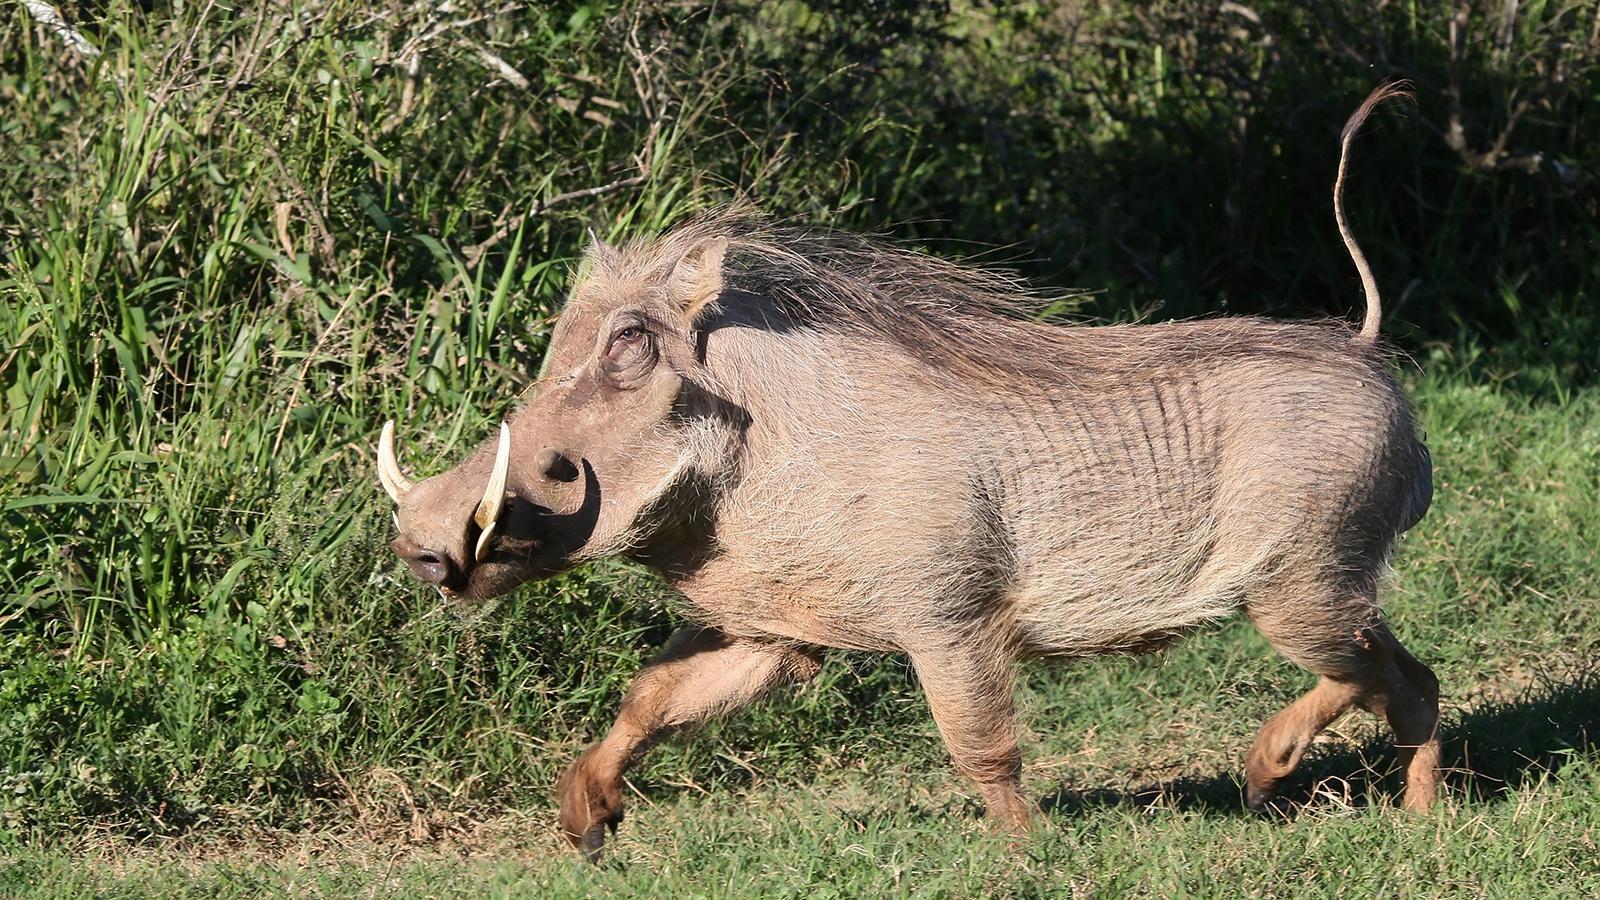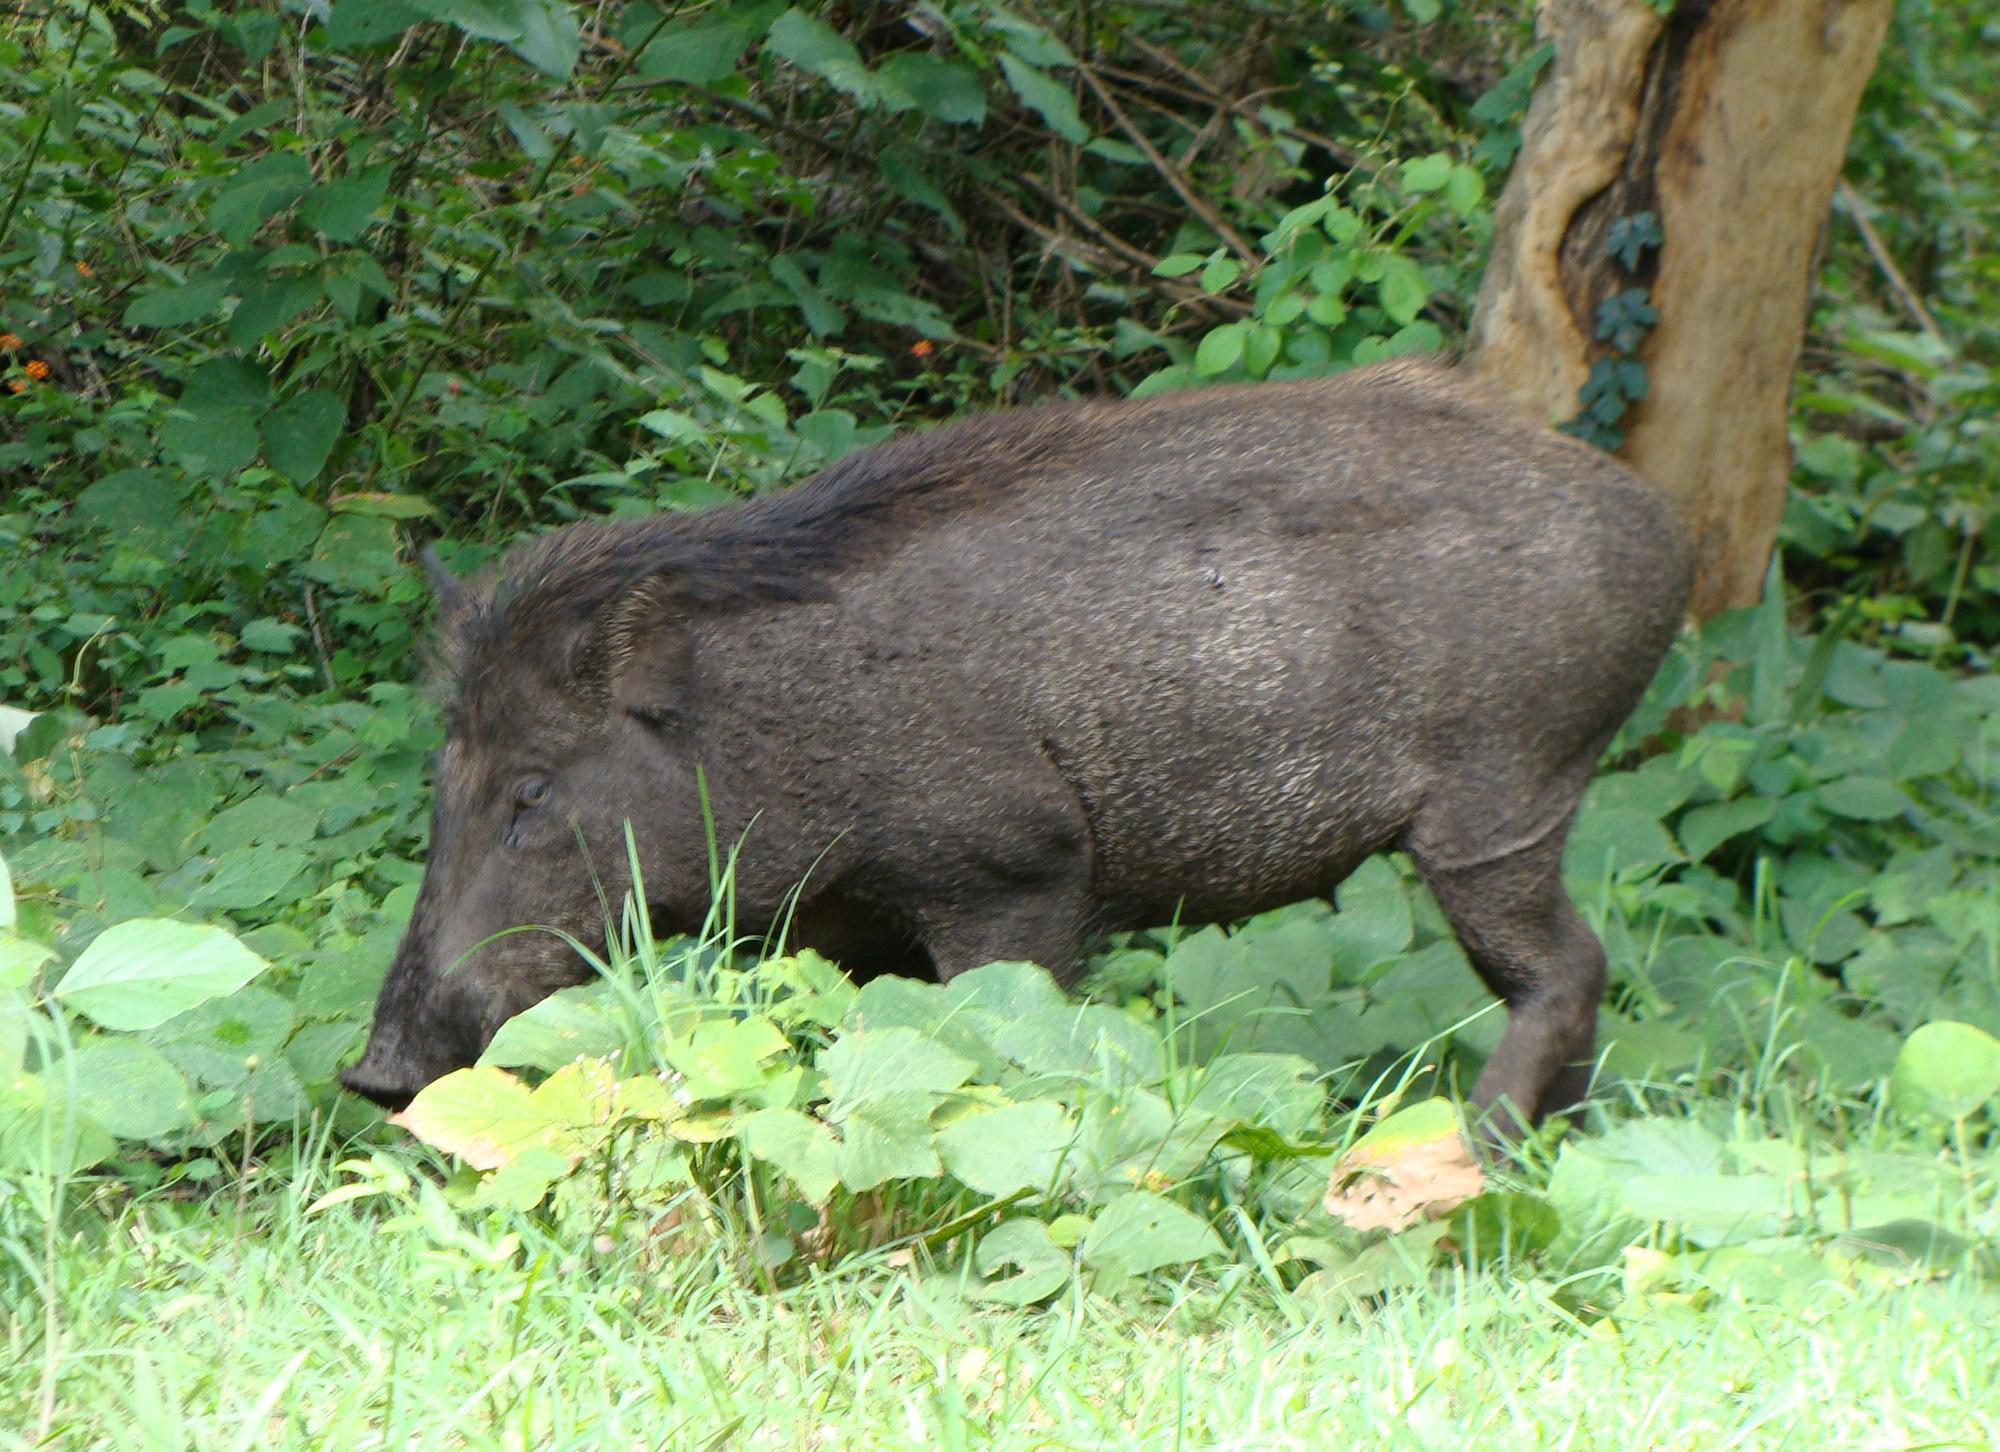The first image is the image on the left, the second image is the image on the right. Evaluate the accuracy of this statement regarding the images: "Three animals, including an adult warthog, are in the left image.". Is it true? Answer yes or no. No. 